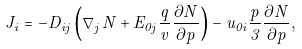<formula> <loc_0><loc_0><loc_500><loc_500>J _ { i } = - D _ { i j } \left ( \nabla _ { j } N + E _ { 0 j } \frac { q } { v } \frac { \partial N } { \partial p } \right ) - { u _ { 0 i } } \frac { p } { 3 } \frac { \partial N } { \partial p } ,</formula> 